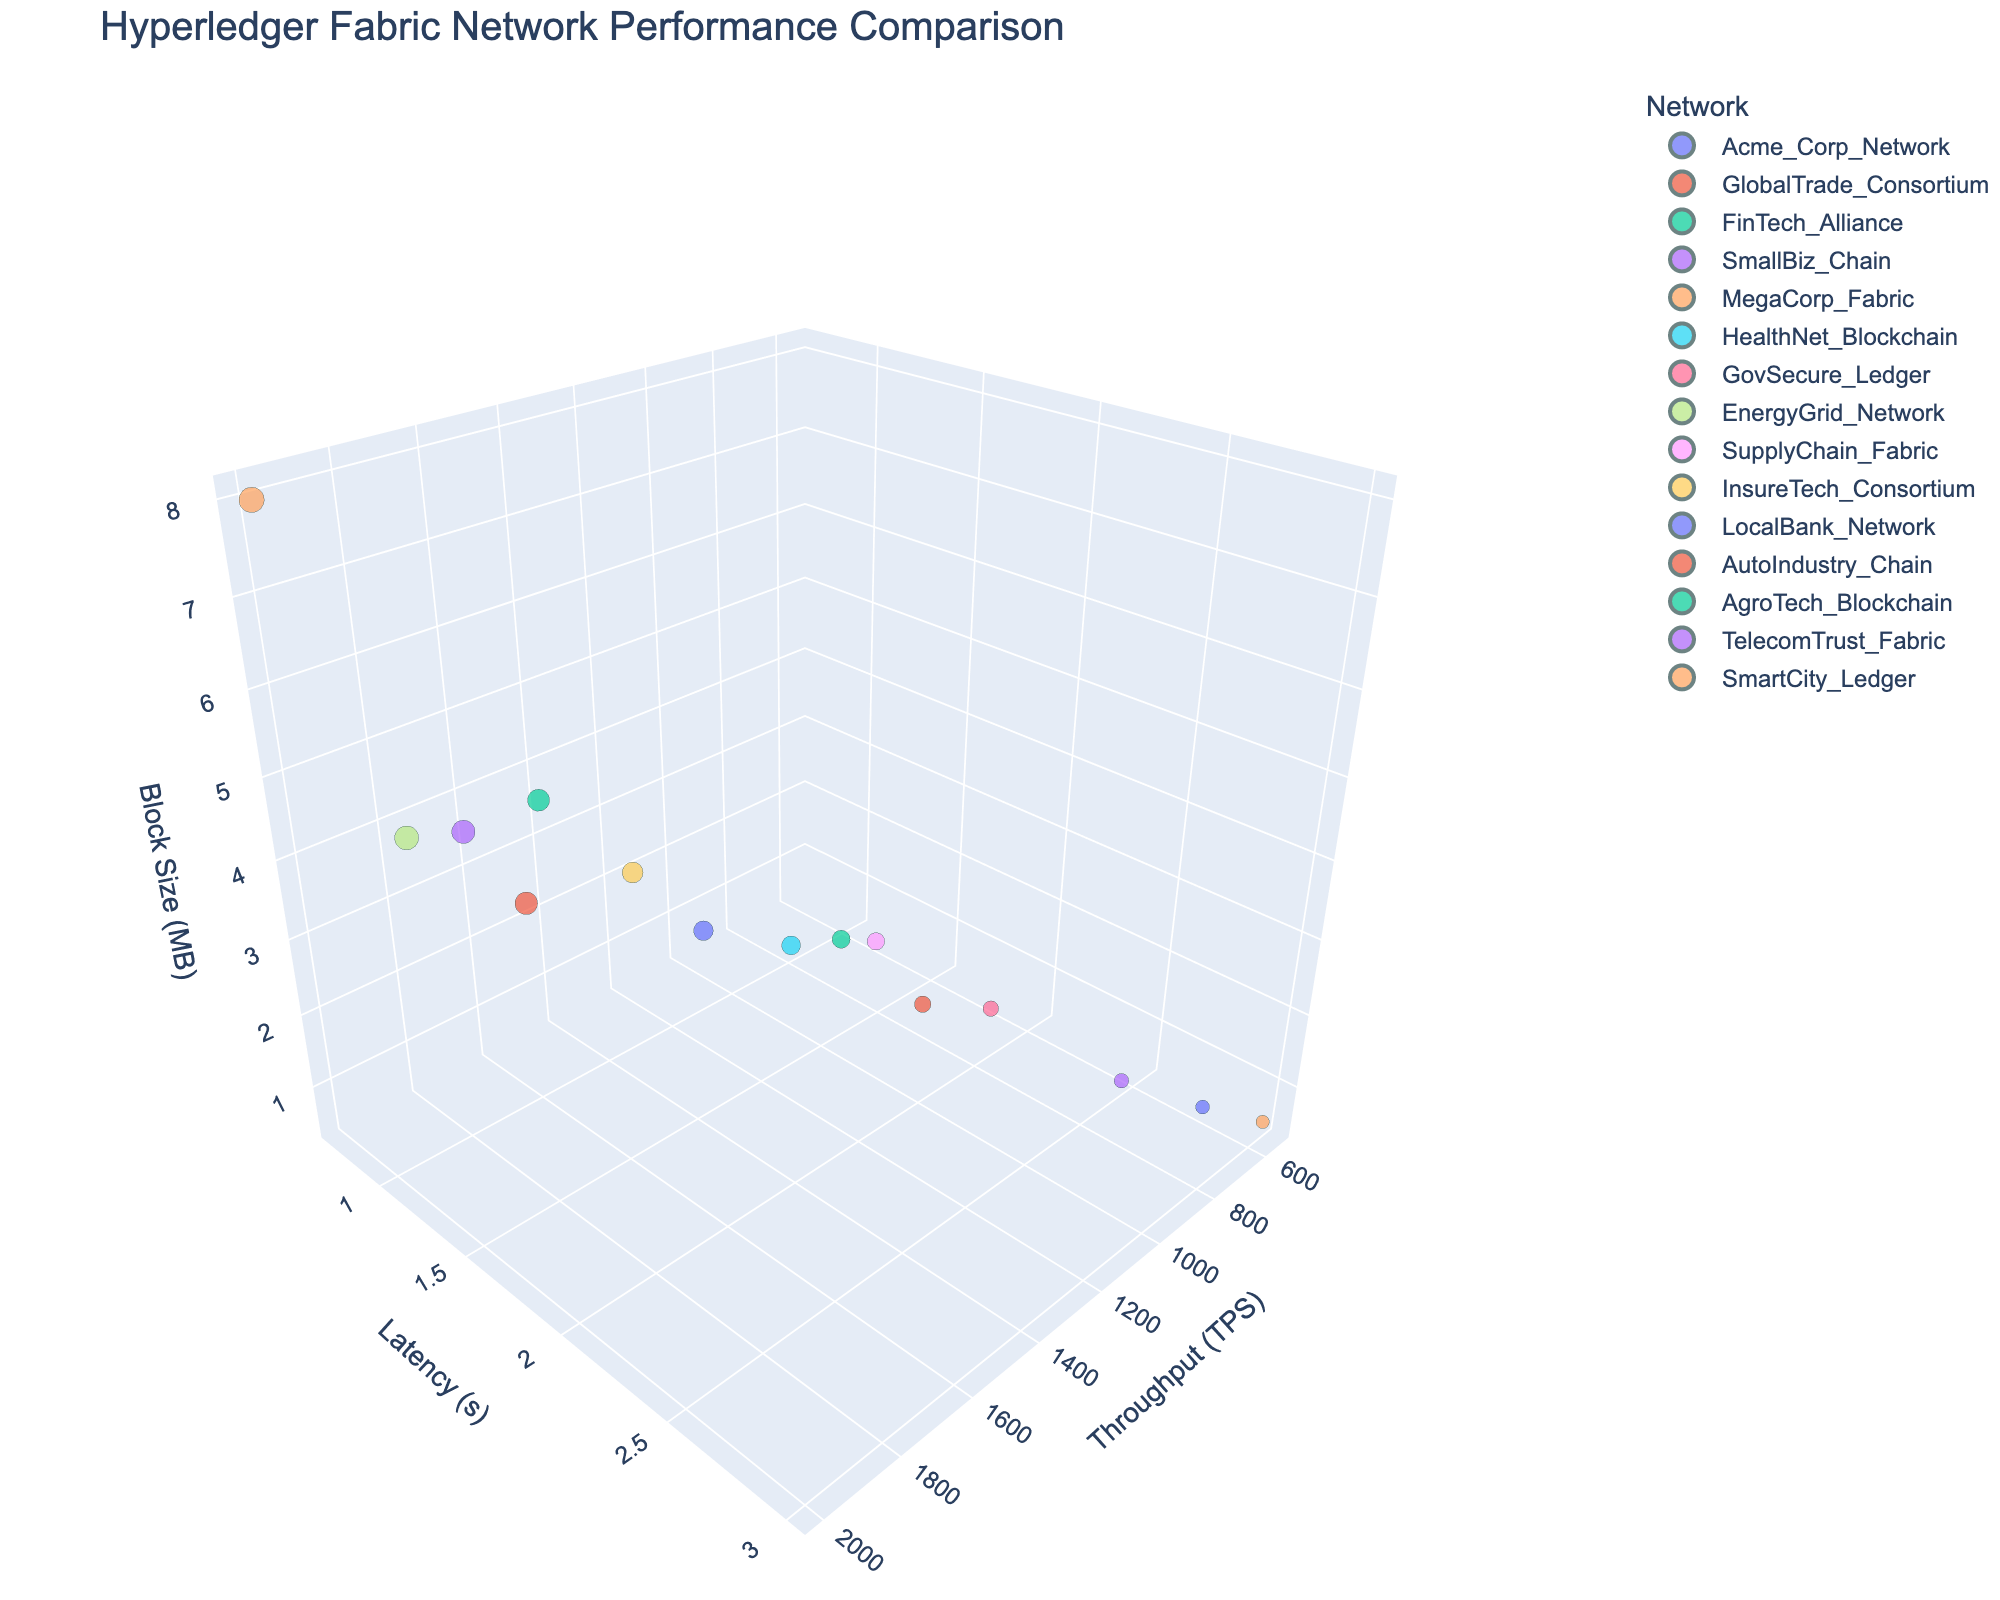What's the title of the figure? The title of the figure is displayed prominently at the top.
Answer: Hyperledger Fabric Network Performance Comparison How many networks have a transaction throughput of over 1500 TPS? Identify the TPS values above 1500 and count the corresponding networks. There are 5 networks: FinTech_Alliance, MegaCorp_Fabric, EnergyGrid_Network, AutoIndustry_Chain, and TelecomTrust_Fabric.
Answer: 5 Which network has the smallest block size and what is it? Look for the smallest value on the Block Size axis and identify the corresponding network, which is represented by the point located at the smallest value (0.5). There are three networks: SmallBiz_Chain, LocalBank_Network, and SmartCity_Ledger.
Answer: SmallBiz_Chain, LocalBank_Network, SmartCity_Ledger each have 0.5 MB What is the latency of MegaCorp_Fabric and how does it compare to HealthNet_Blockchain? Locate the points for MegaCorp_Fabric and HealthNet_Blockchain. MegaCorp_Fabric has a latency of 0.7 seconds, and HealthNet_Blockchain has a latency of 1.5 seconds. MegaCorp_Fabric's latency is lower.
Answer: 0.7 seconds and MegaCorp_Fabric's latency is lower Which network has the highest transaction throughput and what is its block size? Identify the highest value on the Transaction Throughput axis and find the corresponding network and its block size. MegaCorp_Fabric has the highest throughput of 2000 TPS and a block size of 8 MB.
Answer: MegaCorp_Fabric, 8 MB Compare the transaction throughput and latency between Acme_Corp_Network and GlobalTrade_Consortium. Locate the two networks on the plot. Acme_Corp_Network has a throughput of 1200 TPS and a latency of 1.2 seconds. GlobalTrade_Consortium has a throughput of 850 TPS and a latency of 1.8 seconds. Acme_Corp_Network has higher throughput and lower latency.
Answer: Acme_Corp_Network has higher throughput and lower latency What is the average block size of networks with a latency of 1 second or less? Identify networks with latency ≤ 1s (FinTech_Alliance, MegaCorp_Fabric, EnergyGrid_Network, AutoIndustry_Chain, TelecomTrust_Fabric). Their block sizes are: 4, 8, 4, 3, and 4. Average: (4+8+4+3+4)/5 = 4.6 MB.
Answer: 4.6 MB How does the transaction throughput of TelecomTrust_Fabric compare to SupplyChain_Fabric? Identify the two points: TelecomTrust_Fabric (1700 TPS) and SupplyChain_Fabric (950 TPS). TelecomTrust_Fabric has a higher throughput.
Answer: TelecomTrust_Fabric has higher throughput What is the range of latency values in the plot? Locate the minimum and maximum values on the Latency axis. The range is from 0.7 to 3 seconds.
Answer: 0.7 to 3 seconds 